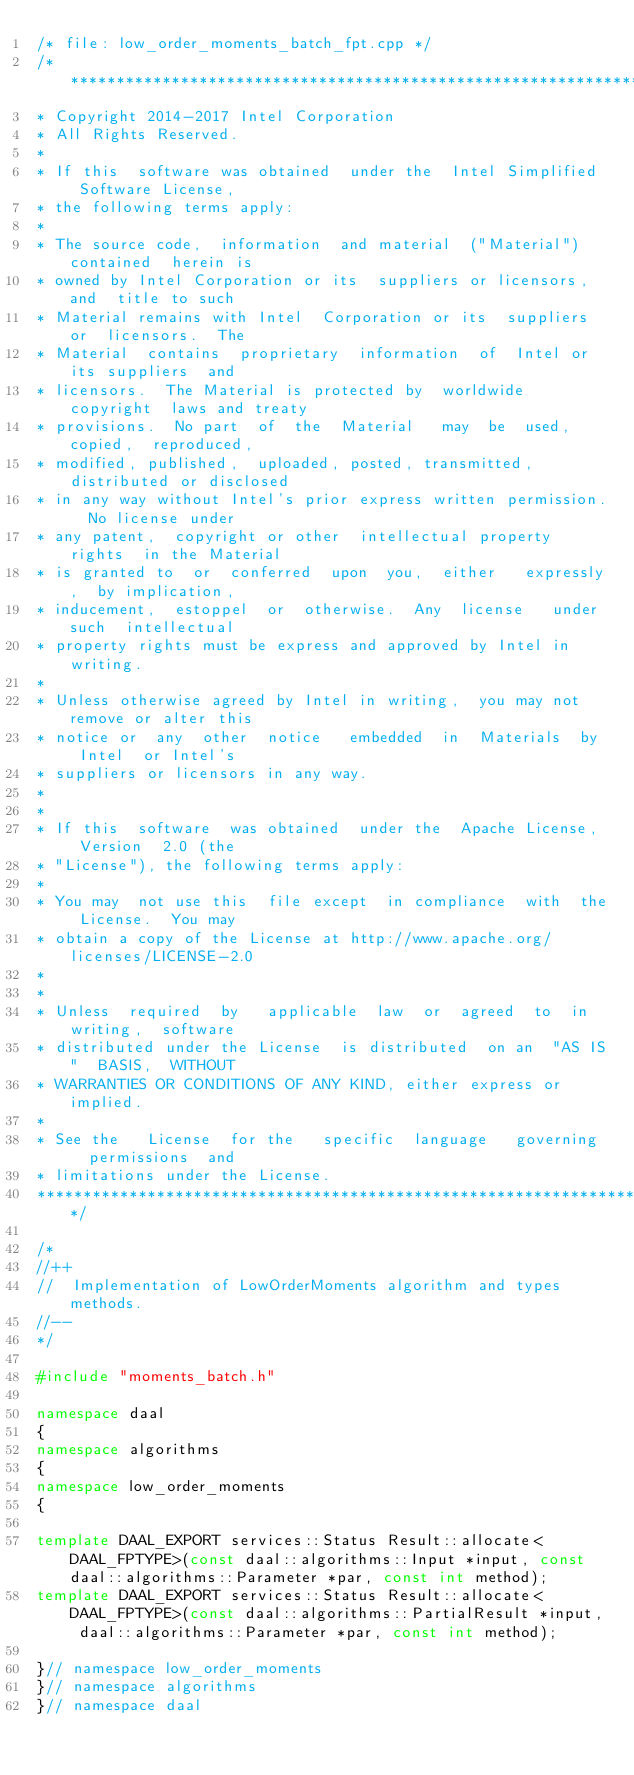Convert code to text. <code><loc_0><loc_0><loc_500><loc_500><_C++_>/* file: low_order_moments_batch_fpt.cpp */
/*******************************************************************************
* Copyright 2014-2017 Intel Corporation
* All Rights Reserved.
*
* If this  software was obtained  under the  Intel Simplified  Software License,
* the following terms apply:
*
* The source code,  information  and material  ("Material") contained  herein is
* owned by Intel Corporation or its  suppliers or licensors,  and  title to such
* Material remains with Intel  Corporation or its  suppliers or  licensors.  The
* Material  contains  proprietary  information  of  Intel or  its suppliers  and
* licensors.  The Material is protected by  worldwide copyright  laws and treaty
* provisions.  No part  of  the  Material   may  be  used,  copied,  reproduced,
* modified, published,  uploaded, posted, transmitted,  distributed or disclosed
* in any way without Intel's prior express written permission.  No license under
* any patent,  copyright or other  intellectual property rights  in the Material
* is granted to  or  conferred  upon  you,  either   expressly,  by implication,
* inducement,  estoppel  or  otherwise.  Any  license   under such  intellectual
* property rights must be express and approved by Intel in writing.
*
* Unless otherwise agreed by Intel in writing,  you may not remove or alter this
* notice or  any  other  notice   embedded  in  Materials  by  Intel  or Intel's
* suppliers or licensors in any way.
*
*
* If this  software  was obtained  under the  Apache License,  Version  2.0 (the
* "License"), the following terms apply:
*
* You may  not use this  file except  in compliance  with  the License.  You may
* obtain a copy of the License at http://www.apache.org/licenses/LICENSE-2.0
*
*
* Unless  required  by   applicable  law  or  agreed  to  in  writing,  software
* distributed under the License  is distributed  on an  "AS IS"  BASIS,  WITHOUT
* WARRANTIES OR CONDITIONS OF ANY KIND, either express or implied.
*
* See the   License  for the   specific  language   governing   permissions  and
* limitations under the License.
*******************************************************************************/

/*
//++
//  Implementation of LowOrderMoments algorithm and types methods.
//--
*/

#include "moments_batch.h"

namespace daal
{
namespace algorithms
{
namespace low_order_moments
{

template DAAL_EXPORT services::Status Result::allocate<DAAL_FPTYPE>(const daal::algorithms::Input *input, const daal::algorithms::Parameter *par, const int method);
template DAAL_EXPORT services::Status Result::allocate<DAAL_FPTYPE>(const daal::algorithms::PartialResult *input, daal::algorithms::Parameter *par, const int method);

}// namespace low_order_moments
}// namespace algorithms
}// namespace daal
</code> 